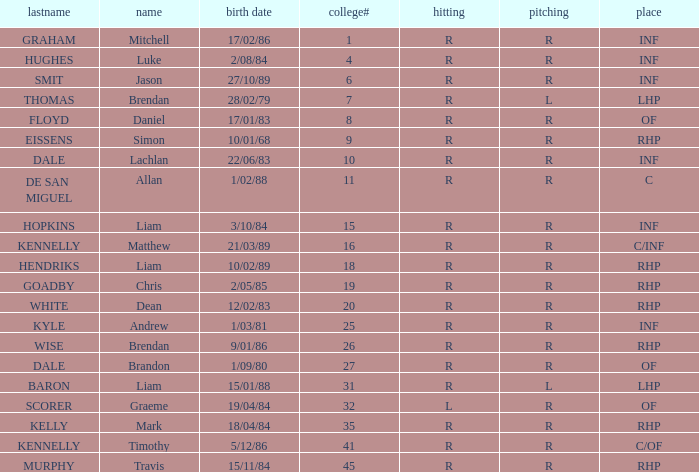Which batter has the last name Graham? R. 